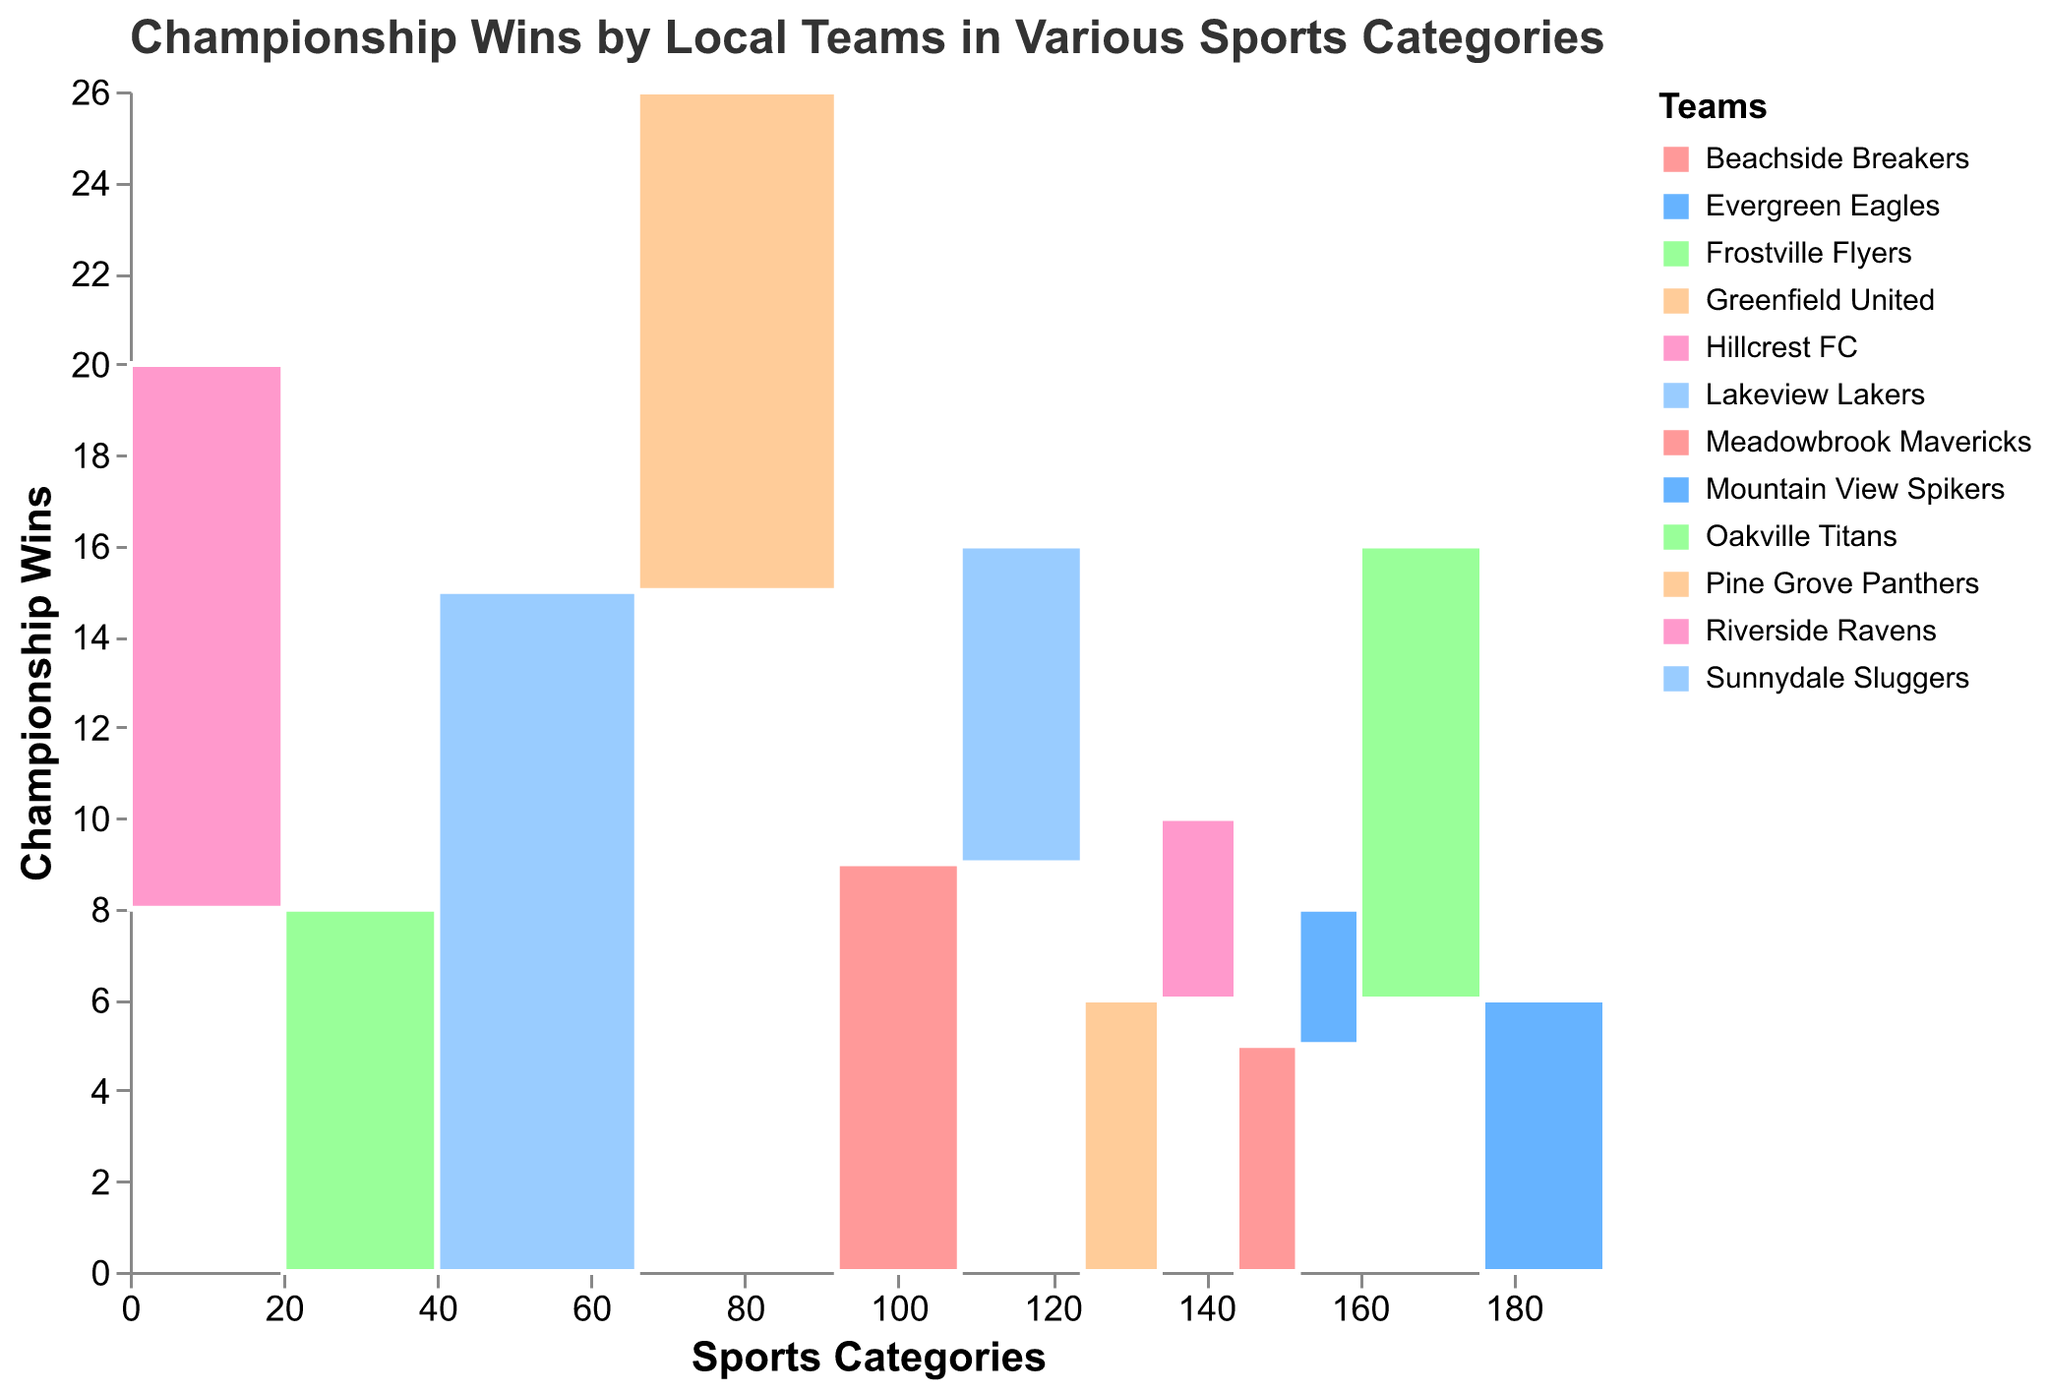What is the title of the figure? The title is typically located at the top of the figure and is meant to provide a brief description of the chart. The title states the main topic or content of the visualization.
Answer: Championship Wins by Local Teams in Various Sports Categories How many championship wins does the team with the most wins have? Look at the bar with the largest segment and find the associated tooltip or legend which indicates the "Total Championships". The largest segment represents the team with 15 wins in Basketball.
Answer: 15 What sport has the fewest total championship wins? Sum the championships for each sport and compare. The sport with the smallest sum is Soccer (6 + 4 = 10 wins).
Answer: Soccer Which football team has more championship wins? Compare the heights of the bars (rectangular segments) for "Riverside Ravens" and "Oakville Titans" under the Football category. "Riverside Ravens" has a taller bar representing 12 wins, whereas "Oakville Titans" has 8 wins.
Answer: Riverside Ravens How many total championships are won in Hockey? Sum the championship wins of both Hockey teams. Refer to the segments for "Frostville Flyers" and "Evergreen Eagles". The sum is 10 + 6 = 16.
Answer: 16 Are there more championship wins in Basketball or Baseball? Summarize the total championship wins for each sport by adding up the values for the teams. Basketball has 15 (Lakeview Lakers) + 11 (Pine Grove Panthers) = 26. Baseball has 9 (Meadowbrook Mavericks) + 7 (Sunnydale Sluggers) = 16. Therefore, Basketball has more wins.
Answer: Basketball Which team has the least number of wins in Volleyball? Look at the Volleyball category and compare the heights of the colored segments representing "Beachside Breakers" and "Mountain View Spikers". "Mountain View Spikers" is shorter with 3 wins.
Answer: Mountain View Spikers What percentage of total football championships does "Oakville Titans" contribute? First, find the total football championships, which is 12 (Riverside Ravens) + 8 (Oakville Titans) = 20. Then divide Oakville Titans' wins by the total and multiply by 100 to find the percentage: (8 / 20) * 100 = 40%.
Answer: 40% Is the sum of championship wins in Soccer equal to that in Volleyball? Add the championship wins for Soccer (6 for Greenfield United + 4 for Hillcrest FC = 10) and Volleyball (5 for Beachside Breakers + 3 for Mountain View Spikers = 8) and compare. Soccer has 10 wins while Volleyball has 8 wins, so they are not equal.
Answer: No 